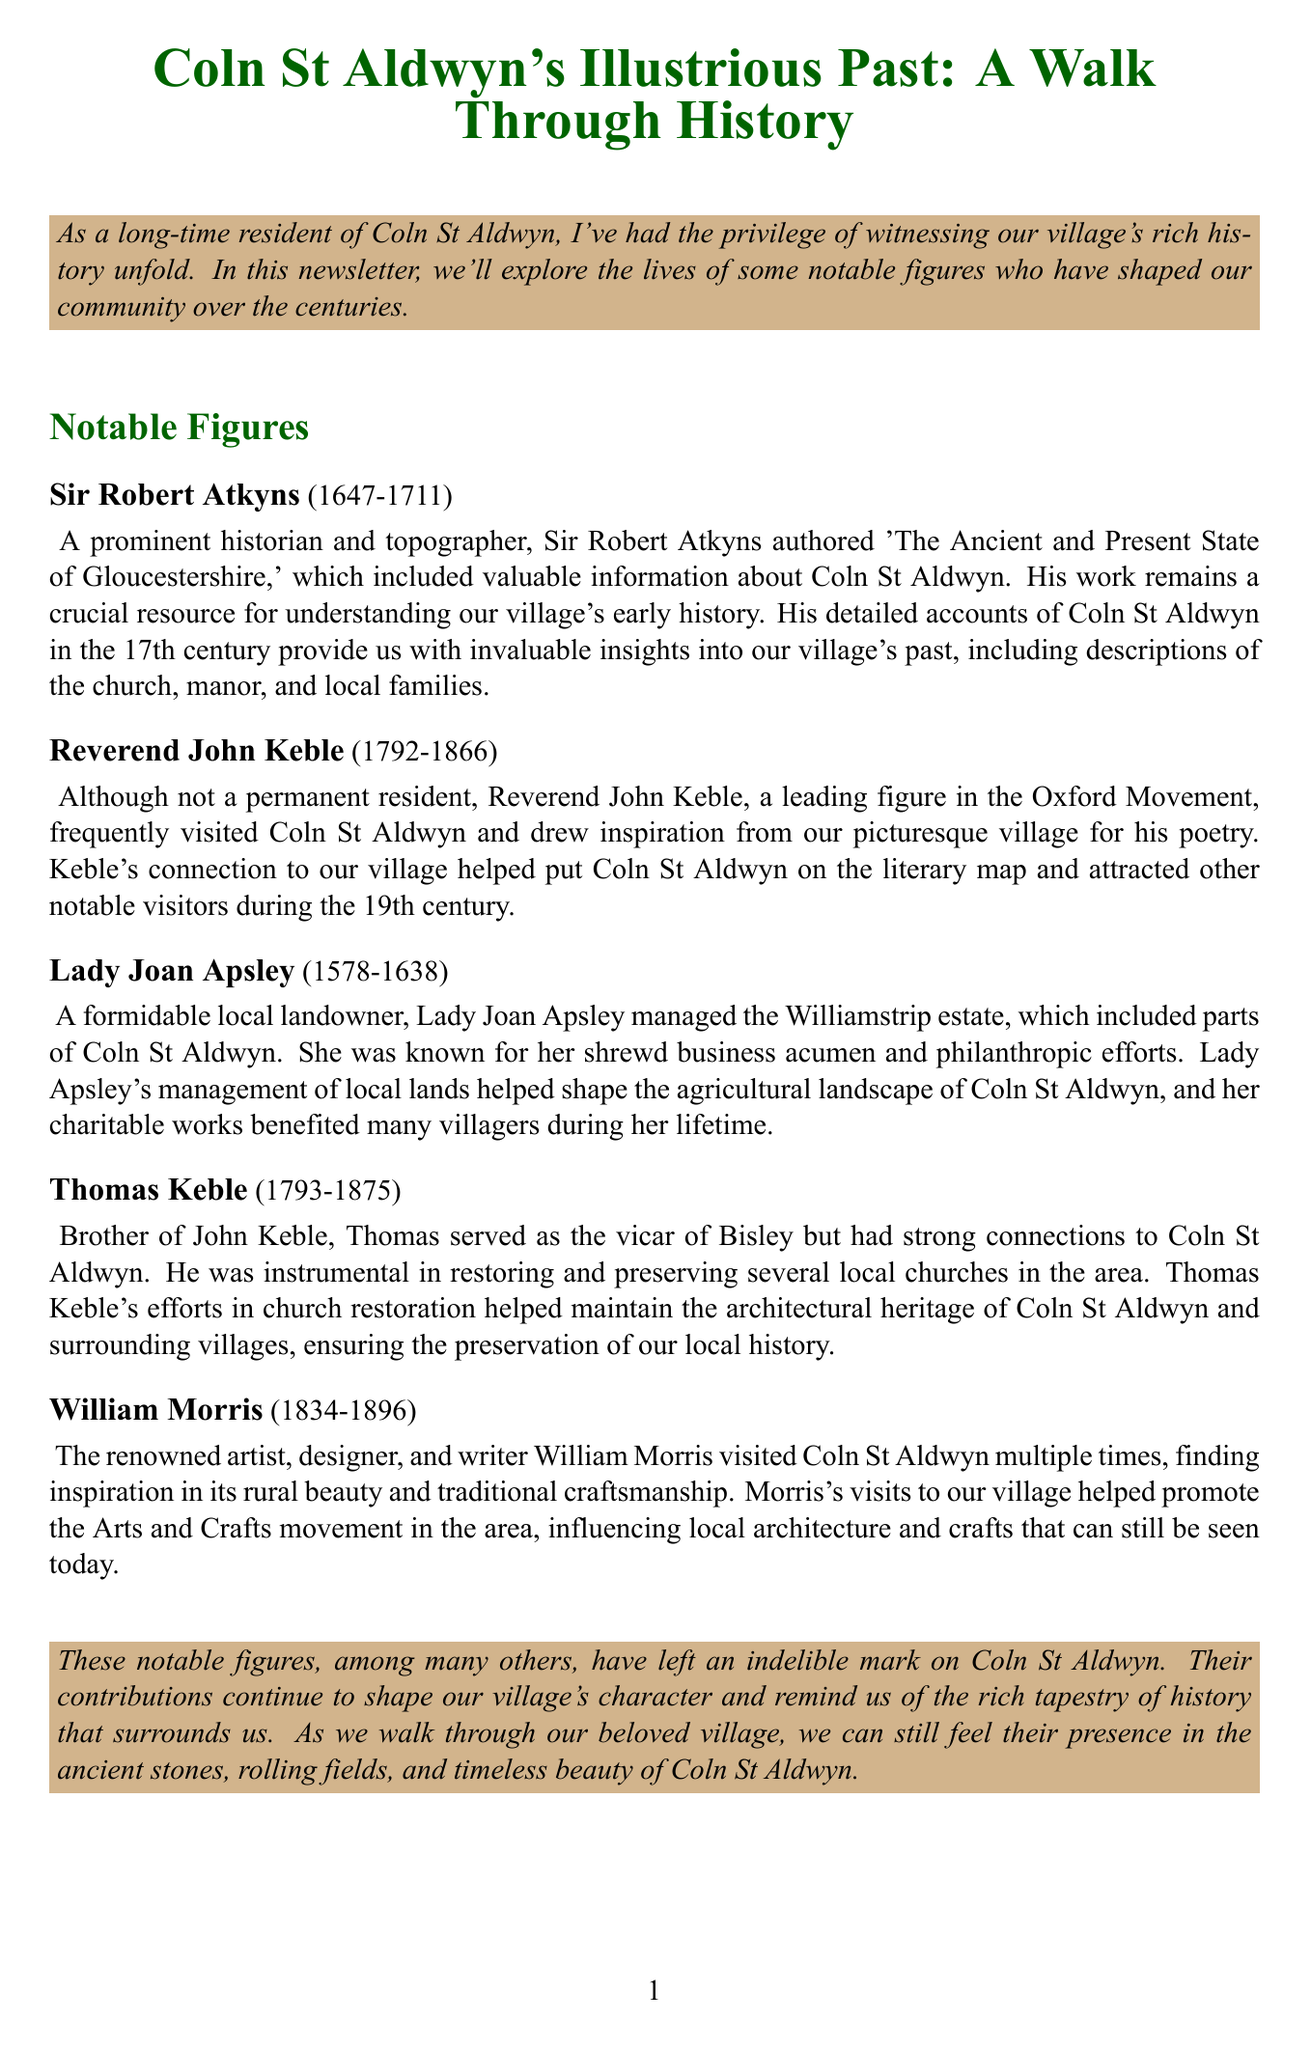What is the title of the newsletter? The title of the newsletter is provided in the heading of the document.
Answer: Coln St Aldwyn's Illustrious Past: A Walk Through History Who authored 'The Ancient and Present State of Gloucestershire'? The document states that Sir Robert Atkyns is the author of this work.
Answer: Sir Robert Atkyns What years did Lady Joan Apsley live? The document specifies the lifespan of Lady Joan Apsley in the biography section.
Answer: 1578-1638 Which notable figure is associated with the Oxford Movement? The biography of Reverend John Keble mentions his connection to this movement.
Answer: Reverend John Keble What was Thomas Keble instrumental in preserving? The document mentions Thomas Keble's role in restoring local churches.
Answer: Local churches What artistic movement did William Morris help promote? The contribution section of William Morris's biography highlights his influence on this movement.
Answer: Arts and Crafts movement What type of documents would enhance the newsletter? The additional notes suggest including images of the historical figures.
Answer: Sketches or portraits How many notable figures are highlighted in the newsletter? The document lists a total of five notable figures in the biographies section.
Answer: Five 